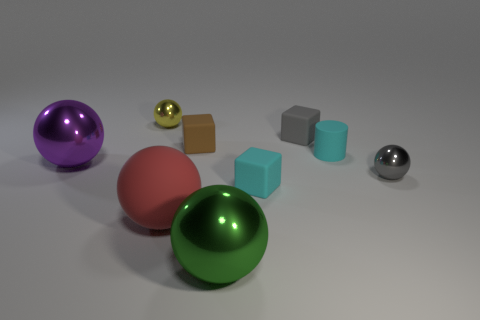What number of large objects are yellow shiny objects or brown cubes?
Keep it short and to the point. 0. Are there any other things that are the same color as the large matte thing?
Keep it short and to the point. No. There is a big purple object; are there any metal balls right of it?
Offer a very short reply. Yes. What size is the rubber cube that is right of the tiny cube in front of the purple metallic thing?
Offer a very short reply. Small. Are there the same number of gray shiny objects that are behind the rubber cylinder and big red matte balls that are right of the small gray matte block?
Make the answer very short. Yes. Is there a tiny gray thing that is in front of the block in front of the gray sphere?
Keep it short and to the point. No. What number of big matte balls are behind the shiny ball to the right of the big metal ball in front of the purple shiny object?
Keep it short and to the point. 0. Is the number of large objects less than the number of big red objects?
Provide a succinct answer. No. There is a big metallic object behind the cyan matte cube; does it have the same shape as the tiny metal thing in front of the yellow metal ball?
Make the answer very short. Yes. What is the color of the matte ball?
Provide a short and direct response. Red. 